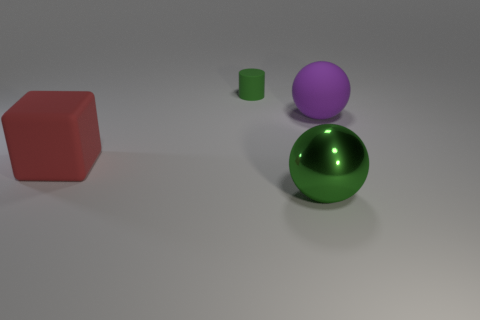There is a ball that is the same color as the cylinder; what material is it?
Your answer should be very brief. Metal. What number of things are either large rubber things that are left of the purple rubber object or metallic cubes?
Make the answer very short. 1. There is a green object that is to the left of the big metallic thing; what number of big green spheres are on the left side of it?
Keep it short and to the point. 0. There is a matte object that is in front of the big ball that is to the right of the green object in front of the green rubber cylinder; what is its size?
Give a very brief answer. Large. Does the ball behind the big red rubber thing have the same color as the tiny matte cylinder?
Ensure brevity in your answer.  No. There is another object that is the same shape as the green metallic thing; what size is it?
Make the answer very short. Large. What number of objects are things in front of the big matte cube or green cylinders that are behind the purple rubber sphere?
Keep it short and to the point. 2. There is a matte thing behind the purple sphere that is behind the metal object; what is its shape?
Provide a succinct answer. Cylinder. Is there any other thing that has the same color as the large metallic thing?
Ensure brevity in your answer.  Yes. Are there any other things that are the same size as the red object?
Your answer should be compact. Yes. 